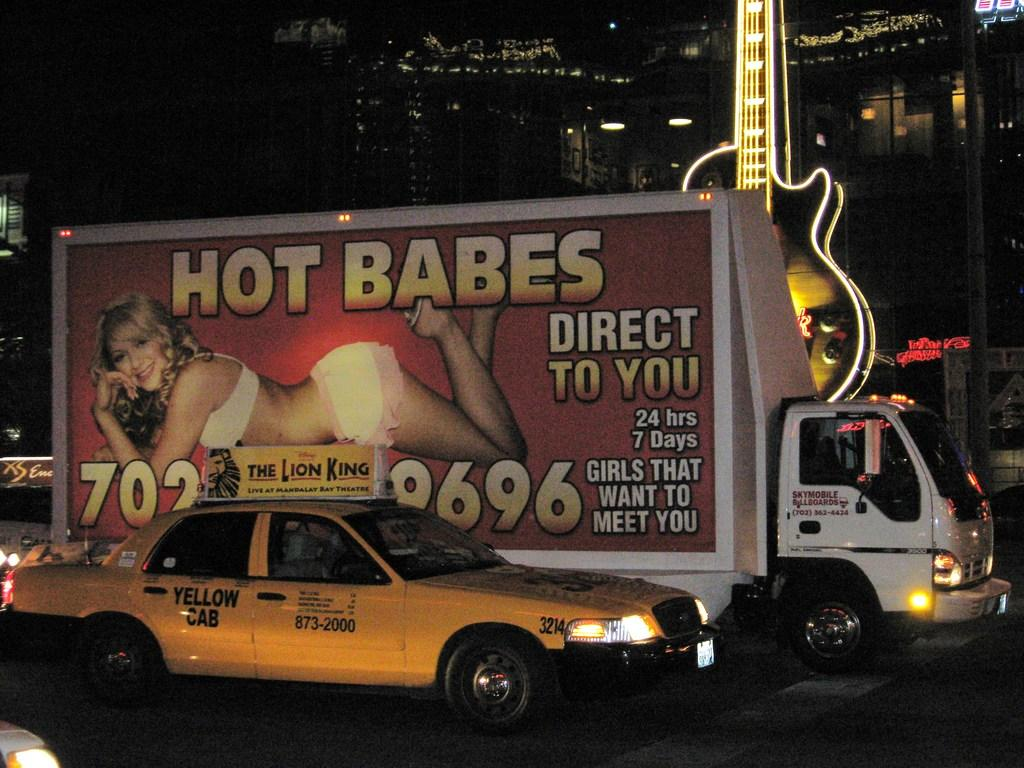<image>
Give a short and clear explanation of the subsequent image. a truck that has 9696 on the side of it 